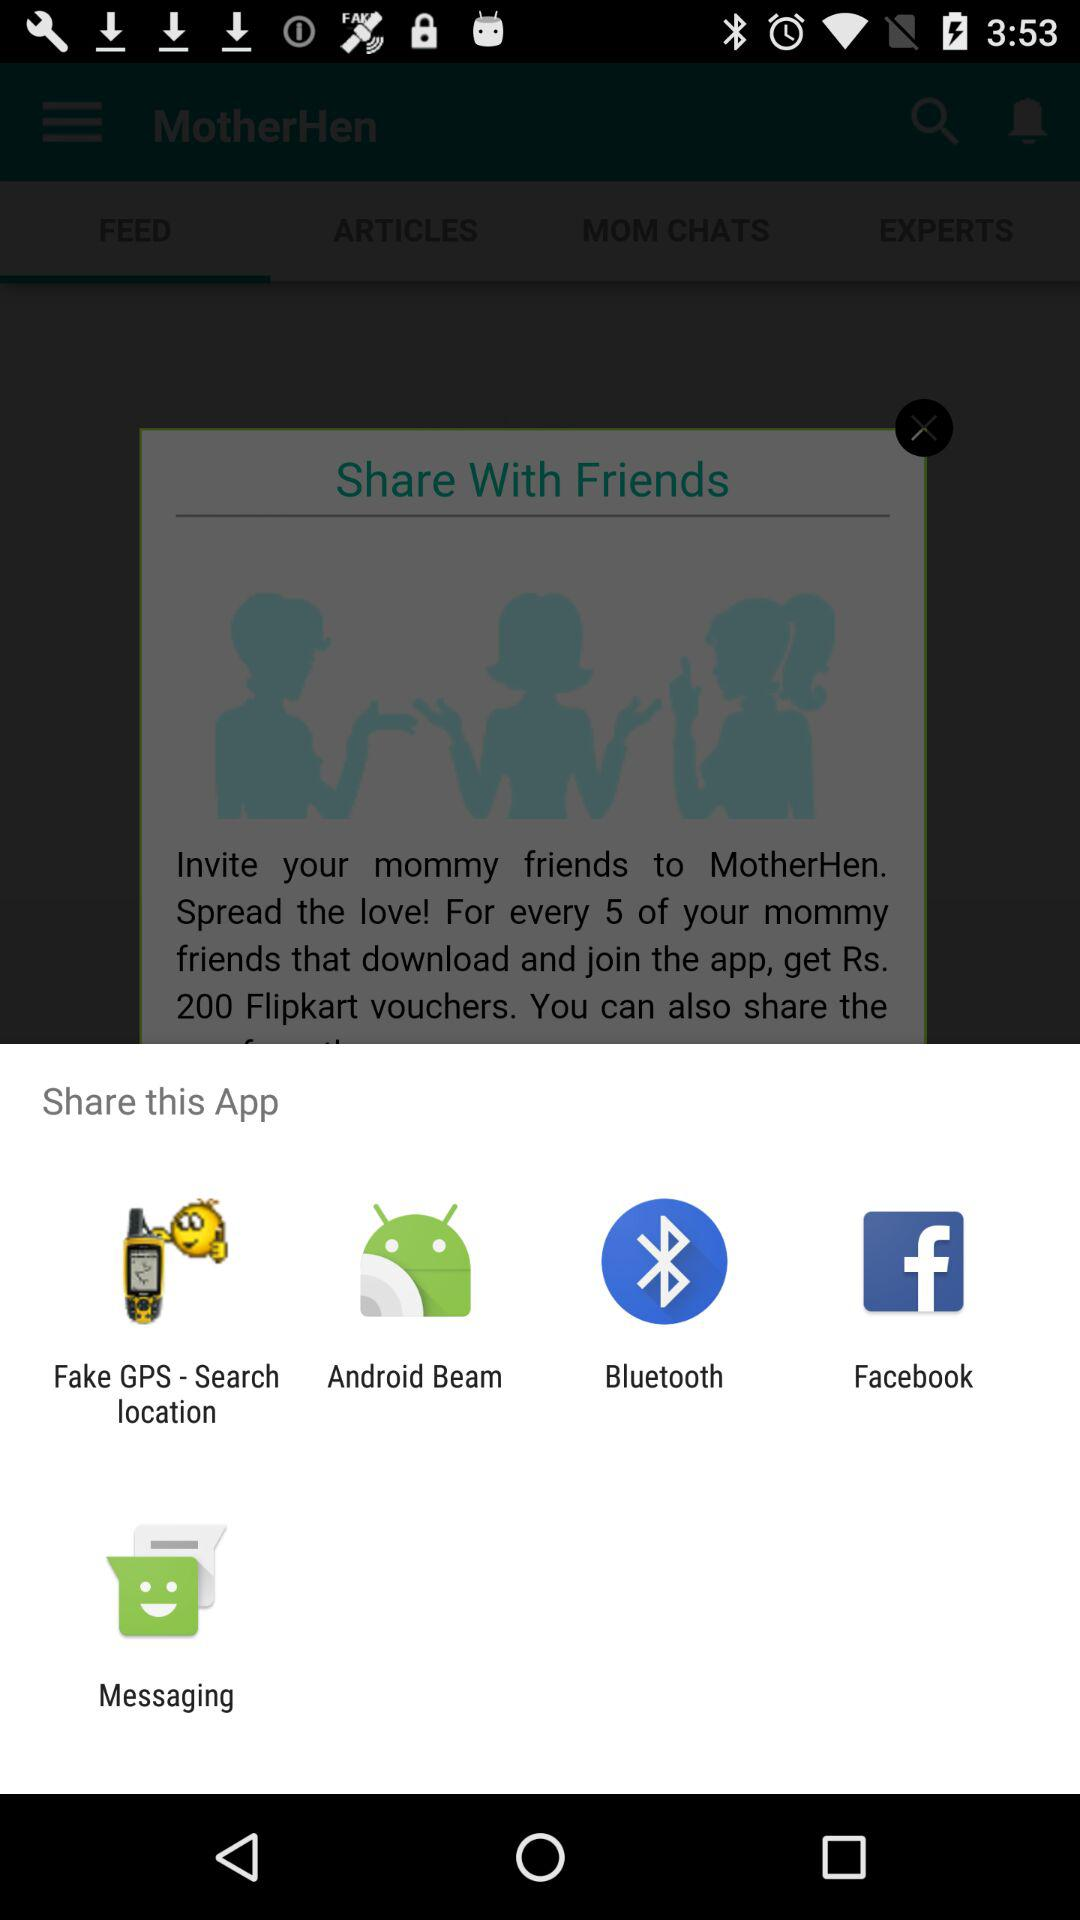Who is sharing this application with friends?
When the provided information is insufficient, respond with <no answer>. <no answer> 